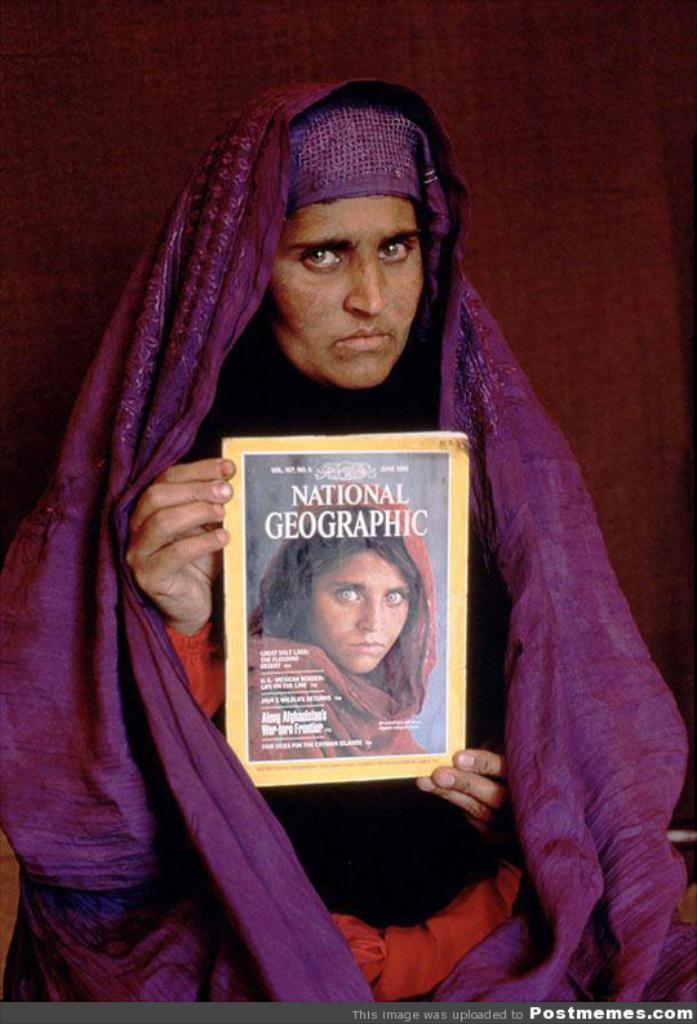How would you summarize this image in a sentence or two? The woman in black and red dress is holding a book in her hands. She is wearing a purple color cloth around her. In the background, it is brown in color. 